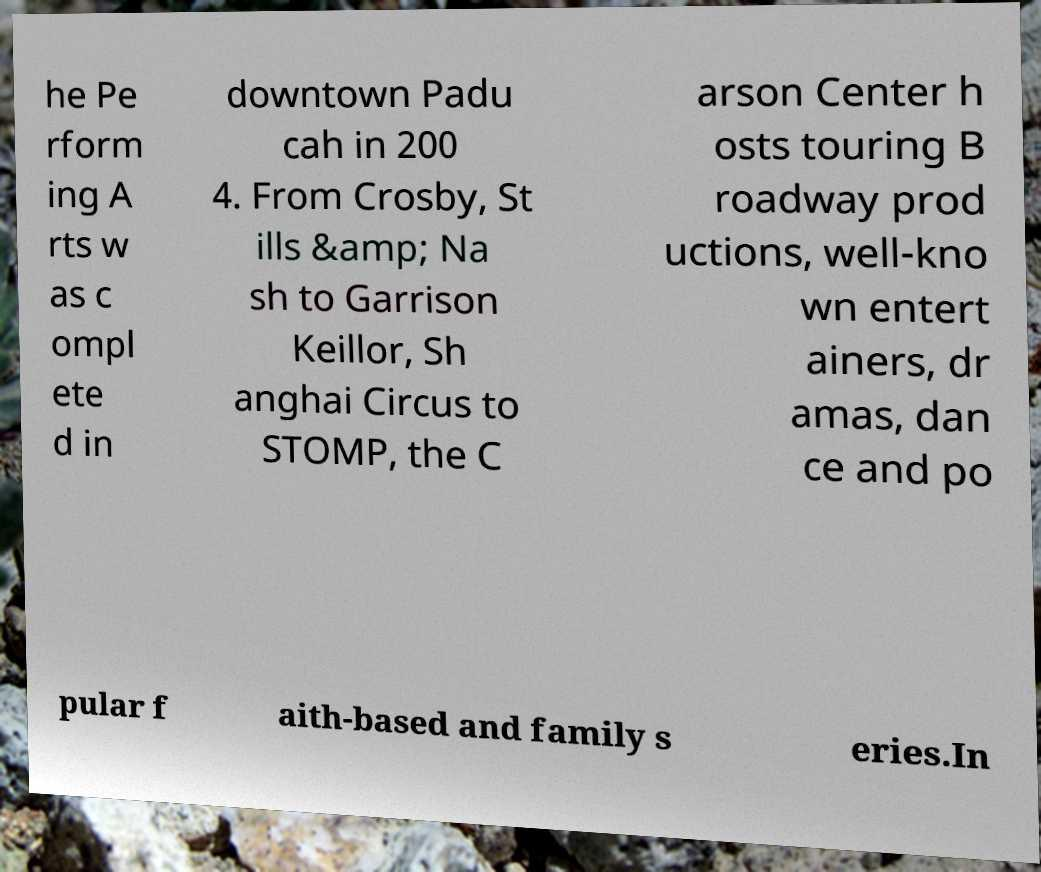What messages or text are displayed in this image? I need them in a readable, typed format. he Pe rform ing A rts w as c ompl ete d in downtown Padu cah in 200 4. From Crosby, St ills &amp; Na sh to Garrison Keillor, Sh anghai Circus to STOMP, the C arson Center h osts touring B roadway prod uctions, well-kno wn entert ainers, dr amas, dan ce and po pular f aith-based and family s eries.In 